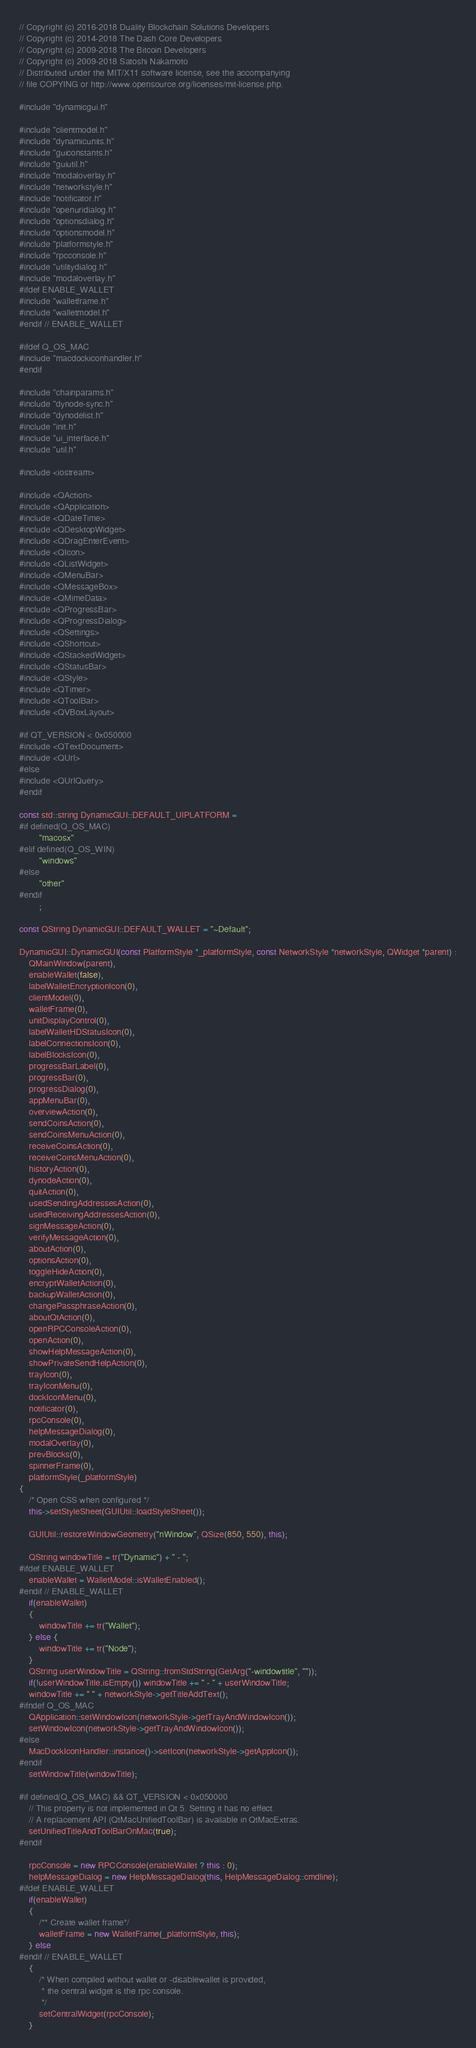<code> <loc_0><loc_0><loc_500><loc_500><_C++_>// Copyright (c) 2016-2018 Duality Blockchain Solutions Developers
// Copyright (c) 2014-2018 The Dash Core Developers
// Copyright (c) 2009-2018 The Bitcoin Developers
// Copyright (c) 2009-2018 Satoshi Nakamoto
// Distributed under the MIT/X11 software license, see the accompanying
// file COPYING or http://www.opensource.org/licenses/mit-license.php.

#include "dynamicgui.h"

#include "clientmodel.h"
#include "dynamicunits.h"
#include "guiconstants.h"
#include "guiutil.h"
#include "modaloverlay.h"
#include "networkstyle.h"
#include "notificator.h"
#include "openuridialog.h"
#include "optionsdialog.h"
#include "optionsmodel.h"
#include "platformstyle.h"
#include "rpcconsole.h"
#include "utilitydialog.h"
#include "modaloverlay.h"
#ifdef ENABLE_WALLET
#include "walletframe.h"
#include "walletmodel.h"
#endif // ENABLE_WALLET

#ifdef Q_OS_MAC
#include "macdockiconhandler.h"
#endif

#include "chainparams.h"
#include "dynode-sync.h"
#include "dynodelist.h"
#include "init.h"
#include "ui_interface.h"
#include "util.h"

#include <iostream>

#include <QAction>
#include <QApplication>
#include <QDateTime>
#include <QDesktopWidget>
#include <QDragEnterEvent>
#include <QIcon>
#include <QListWidget>
#include <QMenuBar>
#include <QMessageBox>
#include <QMimeData>
#include <QProgressBar>
#include <QProgressDialog>
#include <QSettings>
#include <QShortcut>
#include <QStackedWidget>
#include <QStatusBar>
#include <QStyle>
#include <QTimer>
#include <QToolBar>
#include <QVBoxLayout>

#if QT_VERSION < 0x050000
#include <QTextDocument>
#include <QUrl>
#else
#include <QUrlQuery>
#endif

const std::string DynamicGUI::DEFAULT_UIPLATFORM =
#if defined(Q_OS_MAC)
        "macosx"
#elif defined(Q_OS_WIN)
        "windows"
#else
        "other"
#endif
        ;

const QString DynamicGUI::DEFAULT_WALLET = "~Default";

DynamicGUI::DynamicGUI(const PlatformStyle *_platformStyle, const NetworkStyle *networkStyle, QWidget *parent) :
    QMainWindow(parent),
    enableWallet(false),
    labelWalletEncryptionIcon(0),
    clientModel(0),
    walletFrame(0),
    unitDisplayControl(0),
    labelWalletHDStatusIcon(0),
    labelConnectionsIcon(0),
    labelBlocksIcon(0),
    progressBarLabel(0),
    progressBar(0),
    progressDialog(0),
    appMenuBar(0),
    overviewAction(0),
    sendCoinsAction(0),
    sendCoinsMenuAction(0),
    receiveCoinsAction(0),
    receiveCoinsMenuAction(0),
    historyAction(0),
    dynodeAction(0),
    quitAction(0),
    usedSendingAddressesAction(0),
    usedReceivingAddressesAction(0),
    signMessageAction(0),
    verifyMessageAction(0),
    aboutAction(0),
    optionsAction(0),
    toggleHideAction(0),
    encryptWalletAction(0),
    backupWalletAction(0),
    changePassphraseAction(0),
    aboutQtAction(0),
    openRPCConsoleAction(0),
    openAction(0),
    showHelpMessageAction(0),
    showPrivateSendHelpAction(0),
    trayIcon(0),
    trayIconMenu(0),
    dockIconMenu(0),
    notificator(0),
    rpcConsole(0),
    helpMessageDialog(0),
    modalOverlay(0),
    prevBlocks(0),
    spinnerFrame(0),
    platformStyle(_platformStyle)
{
    /* Open CSS when configured */
    this->setStyleSheet(GUIUtil::loadStyleSheet());

    GUIUtil::restoreWindowGeometry("nWindow", QSize(850, 550), this);

    QString windowTitle = tr("Dynamic") + " - ";
#ifdef ENABLE_WALLET
    enableWallet = WalletModel::isWalletEnabled();
#endif // ENABLE_WALLET
    if(enableWallet)
    {
        windowTitle += tr("Wallet");
    } else {
        windowTitle += tr("Node");
    }
    QString userWindowTitle = QString::fromStdString(GetArg("-windowtitle", ""));
    if(!userWindowTitle.isEmpty()) windowTitle += " - " + userWindowTitle;
    windowTitle += " " + networkStyle->getTitleAddText();
#ifndef Q_OS_MAC
    QApplication::setWindowIcon(networkStyle->getTrayAndWindowIcon());
    setWindowIcon(networkStyle->getTrayAndWindowIcon());
#else
    MacDockIconHandler::instance()->setIcon(networkStyle->getAppIcon());
#endif
    setWindowTitle(windowTitle);

#if defined(Q_OS_MAC) && QT_VERSION < 0x050000
    // This property is not implemented in Qt 5. Setting it has no effect.
    // A replacement API (QtMacUnifiedToolBar) is available in QtMacExtras.
    setUnifiedTitleAndToolBarOnMac(true);
#endif

    rpcConsole = new RPCConsole(enableWallet ? this : 0);
    helpMessageDialog = new HelpMessageDialog(this, HelpMessageDialog::cmdline);
#ifdef ENABLE_WALLET
    if(enableWallet)
    {
        /** Create wallet frame*/
        walletFrame = new WalletFrame(_platformStyle, this);
    } else
#endif // ENABLE_WALLET
    {
        /* When compiled without wallet or -disablewallet is provided,
         * the central widget is the rpc console.
         */
        setCentralWidget(rpcConsole);
    }
</code> 